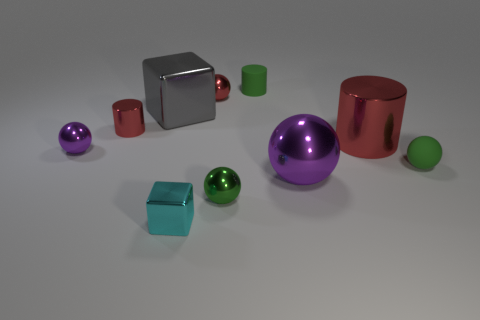The large metallic object that is left of the small green matte cylinder has what shape? cube 